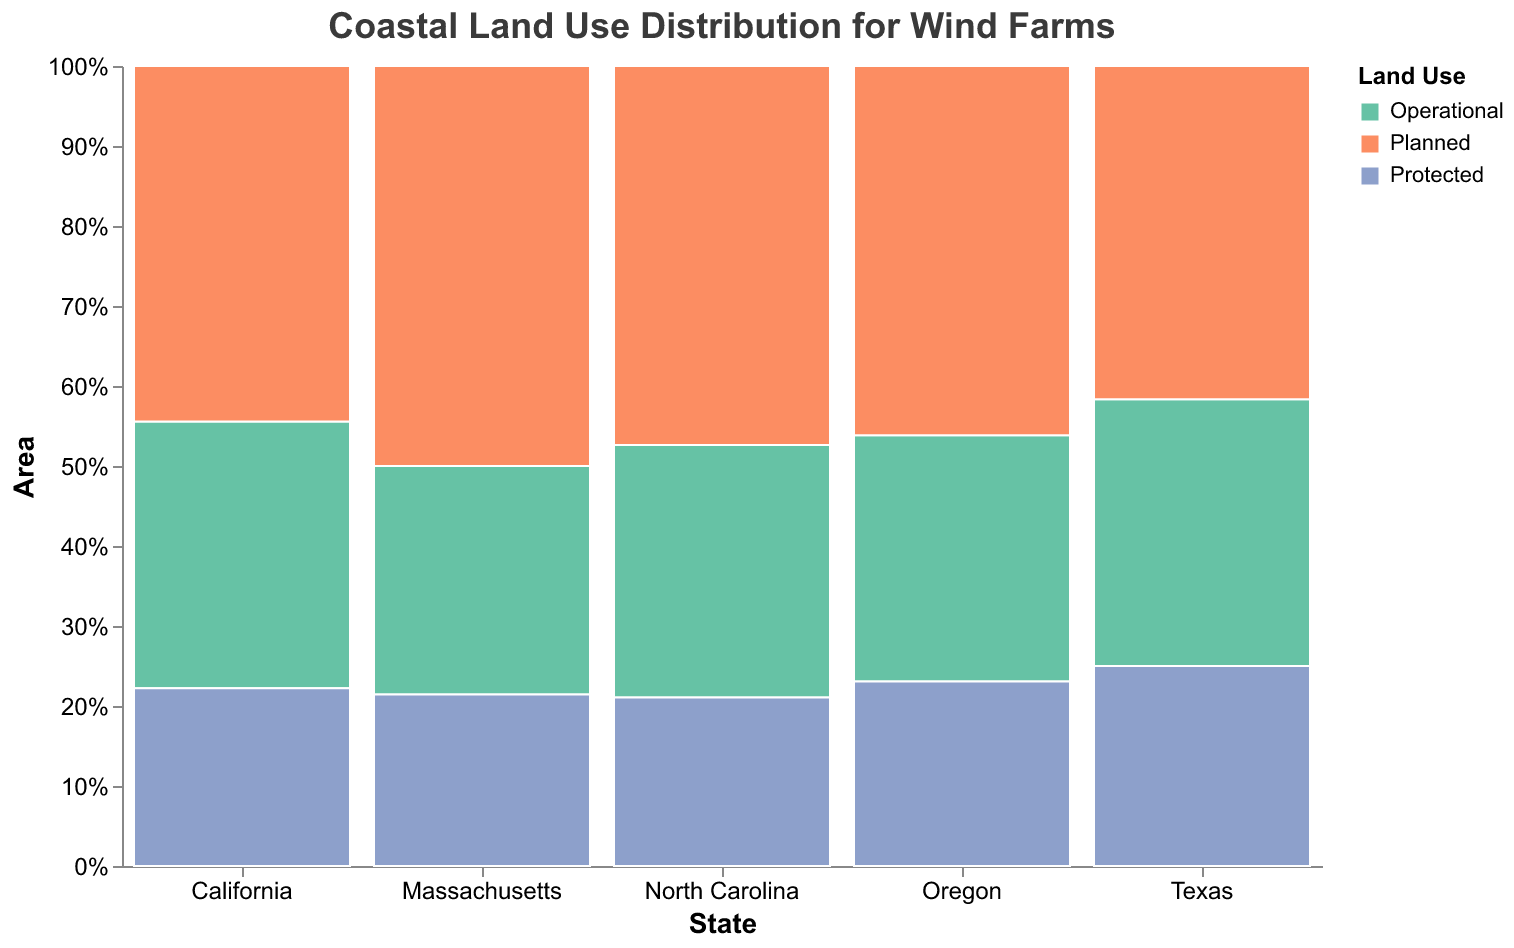What is the title of the plot? The title is located at the top of the figure and it provides a concise description of the content of the plot.
Answer: Coastal Land Use Distribution for Wind Farms Which state has the highest total area of wind farm land use? By observing the heights of the bars stacked together for each state on the x-axis, it is evident which state has the highest total area.
Answer: Texas How much area in California is planned for wind farms? We refer to the height of the bar section labeled 'Planned' in California's x-axis location; the tooltip might also display the exact value.
Answer: 200 sq km Compare the environmental impact categories in Texas: Which category has the highest area? Analyze the height of each bar section labeled 'Operational', 'Planned', and 'Protected' within Texas’s x-axis location to find which one is the highest.
Answer: Planned Which state has the lowest area of operational wind farm land use? Check the height of the 'Operational' section of the bar for each state; the one with the smallest section is the answer.
Answer: Massachusetts What is the combined area of protected land use in California and Oregon for wind farms? Add the 'Protected' area values for both California and Oregon: 100 sq km for California and 60 sq km for Oregon: (100 + 60).
Answer: 160 sq km How does the area of planned wind farm land use in North Carolina compare to that in Massachusetts? Compare the 'Planned' section heights for North Carolina and Massachusetts; North Carolina's value is 90 sq km and Massachusetts's value is 70 sq km.
Answer: North Carolina has more What percentage of wind farm land in Oregon has a high environmental impact? Sum all areas in Oregon, find the percentage of the 'Protected' area: total areas are (80 + 120 + 60) = 260 sq km, 'Protected' area is 60 sq km; calculate (60/260) * 100.
Answer: 23.08% Which state has the most balanced distribution of land use categories? Observe states where the areas for 'Operational', 'Planned', and 'Protected' are most similar in proportion; compare the sizes of each section for each state.
Answer: Oregon What is the relationship between land use and environmental impact in Massachusetts? Inspect how the areas of 'Operational', 'Planned', and 'Protected' in Massachusetts distribute across environmental impact categories; observe the sections of the bar aligned vertically for Massachusetts.
Answer: 'Operational' has low impact, 'Planned' has moderate impact, 'Protected' has high impact 